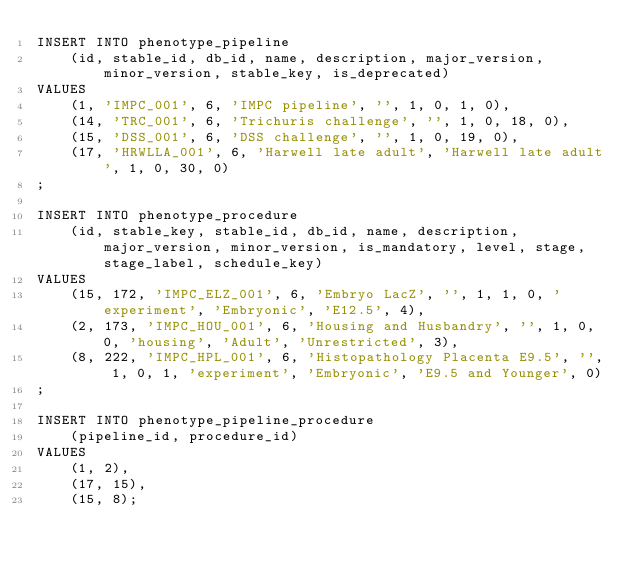Convert code to text. <code><loc_0><loc_0><loc_500><loc_500><_SQL_>INSERT INTO phenotype_pipeline
    (id, stable_id, db_id, name, description, major_version, minor_version, stable_key, is_deprecated)
VALUES
    (1, 'IMPC_001', 6, 'IMPC pipeline', '', 1, 0, 1, 0),
    (14, 'TRC_001', 6, 'Trichuris challenge', '', 1, 0, 18, 0),
    (15, 'DSS_001', 6, 'DSS challenge', '', 1, 0, 19, 0),
    (17, 'HRWLLA_001', 6, 'Harwell late adult', 'Harwell late adult', 1, 0, 30, 0)
;

INSERT INTO phenotype_procedure
    (id, stable_key, stable_id, db_id, name, description, major_version, minor_version, is_mandatory, level, stage, stage_label, schedule_key)
VALUES
    (15, 172, 'IMPC_ELZ_001', 6, 'Embryo LacZ', '', 1, 1, 0, 'experiment', 'Embryonic', 'E12.5', 4),
    (2, 173, 'IMPC_HOU_001', 6, 'Housing and Husbandry', '', 1, 0, 0, 'housing', 'Adult', 'Unrestricted', 3),
    (8, 222, 'IMPC_HPL_001', 6, 'Histopathology Placenta E9.5', '', 1, 0, 1, 'experiment', 'Embryonic', 'E9.5 and Younger', 0)
;

INSERT INTO phenotype_pipeline_procedure
    (pipeline_id, procedure_id)
VALUES
    (1, 2),
    (17, 15),
    (15, 8);</code> 